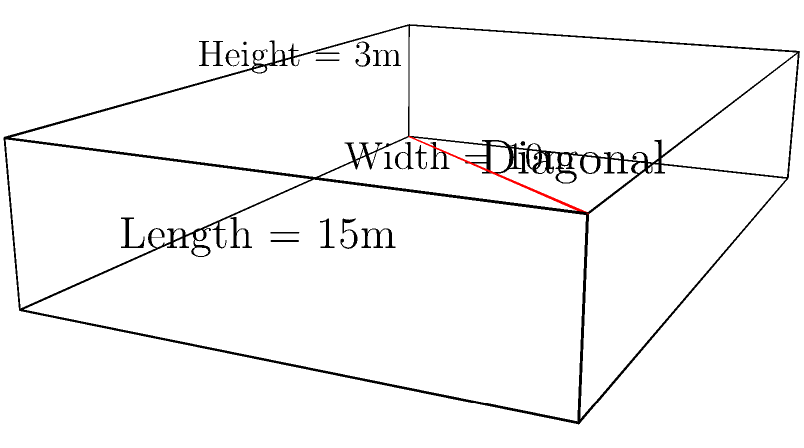A new trading firm is designing its main trading floor. The rectangular floor measures 15 meters in length, 10 meters in width, and has a ceiling height of 3 meters. To ensure proper WiFi coverage, they need to calculate the longest possible distance within this space. What is the length of the diagonal from one bottom corner to the opposite top corner of this trading floor? To solve this problem, we'll use the three-dimensional version of the Pythagorean theorem, also known as the distance formula in 3D space.

Step 1: Identify the dimensions
Length (l) = 15 m
Width (w) = 10 m
Height (h) = 3 m

Step 2: Apply the 3D distance formula
The diagonal (d) can be calculated using the formula:
$$d = \sqrt{l^2 + w^2 + h^2}$$

Step 3: Substitute the values
$$d = \sqrt{15^2 + 10^2 + 3^2}$$

Step 4: Calculate
$$d = \sqrt{225 + 100 + 9}$$
$$d = \sqrt{334}$$

Step 5: Simplify
$$d \approx 18.28 \text{ m}$$

Therefore, the diagonal length of the trading floor is approximately 18.28 meters.
Answer: 18.28 m 